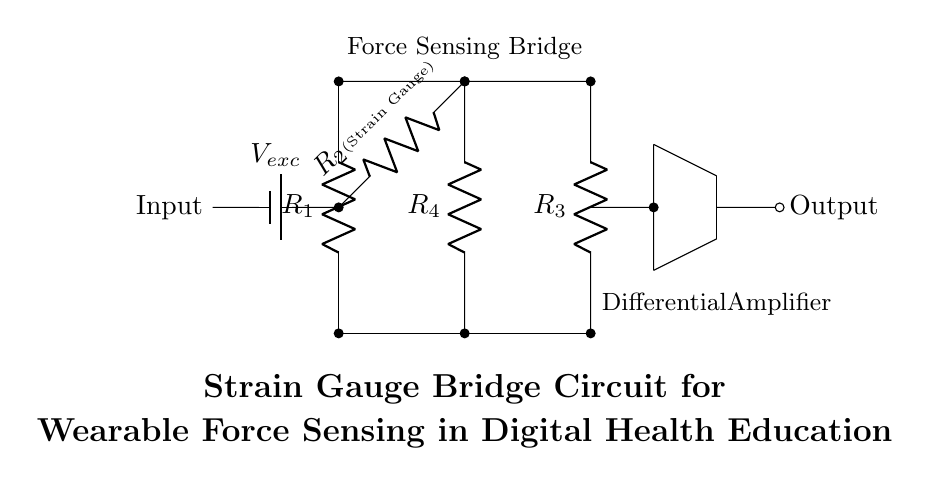What is the type of this circuit? The circuit is a bridge circuit, which is characterized by four resistors arranged in a diamond shape, typically used to measure small changes in resistance, such as those caused by strain in a strain gauge.
Answer: Bridge circuit What component serves as the strain gauge in this circuit? The role of the strain gauge is fulfilled by resistor R2, which is specifically labeled as a strain gauge, indicating its function in the circuit to detect force or deformation.
Answer: R2 (Strain Gauge) What is the input voltage labeled in the circuit? The input voltage is labeled as Vexc, indicating it is the excitation voltage provided to the bridge circuit to operate the strain gauge and power the circuit.
Answer: Vexc Which component amplifies the output signal in this circuit? The component responsible for amplifying the output signal is the differential amplifier, which is clearly marked as the part that takes the signal from the bridge and increases its magnitude for easier observation.
Answer: Differential Amplifier How many resistors are used in the bridge circuit? There are four resistors used in the bridge circuit, which are labeled R1, R2 (strain gauge), R3, and R4, forming the essential arrangement for the bridge configuration.
Answer: Four What function does the battery serve in the circuit? The battery provides the excitation voltage (labeled as Vexc) necessary for the operation of the strain gauge bridge circuit, ensuring that it can detect changes in resistance accurately.
Answer: Excitation voltage supply What does the differential amplifier output represent? The output of the differential amplifier represents the difference in voltage across the bridge, which correlates to the amount of strain detected by the strain gauge (R2), translating physical force into an electrical signal.
Answer: Difference in voltage across the bridge 